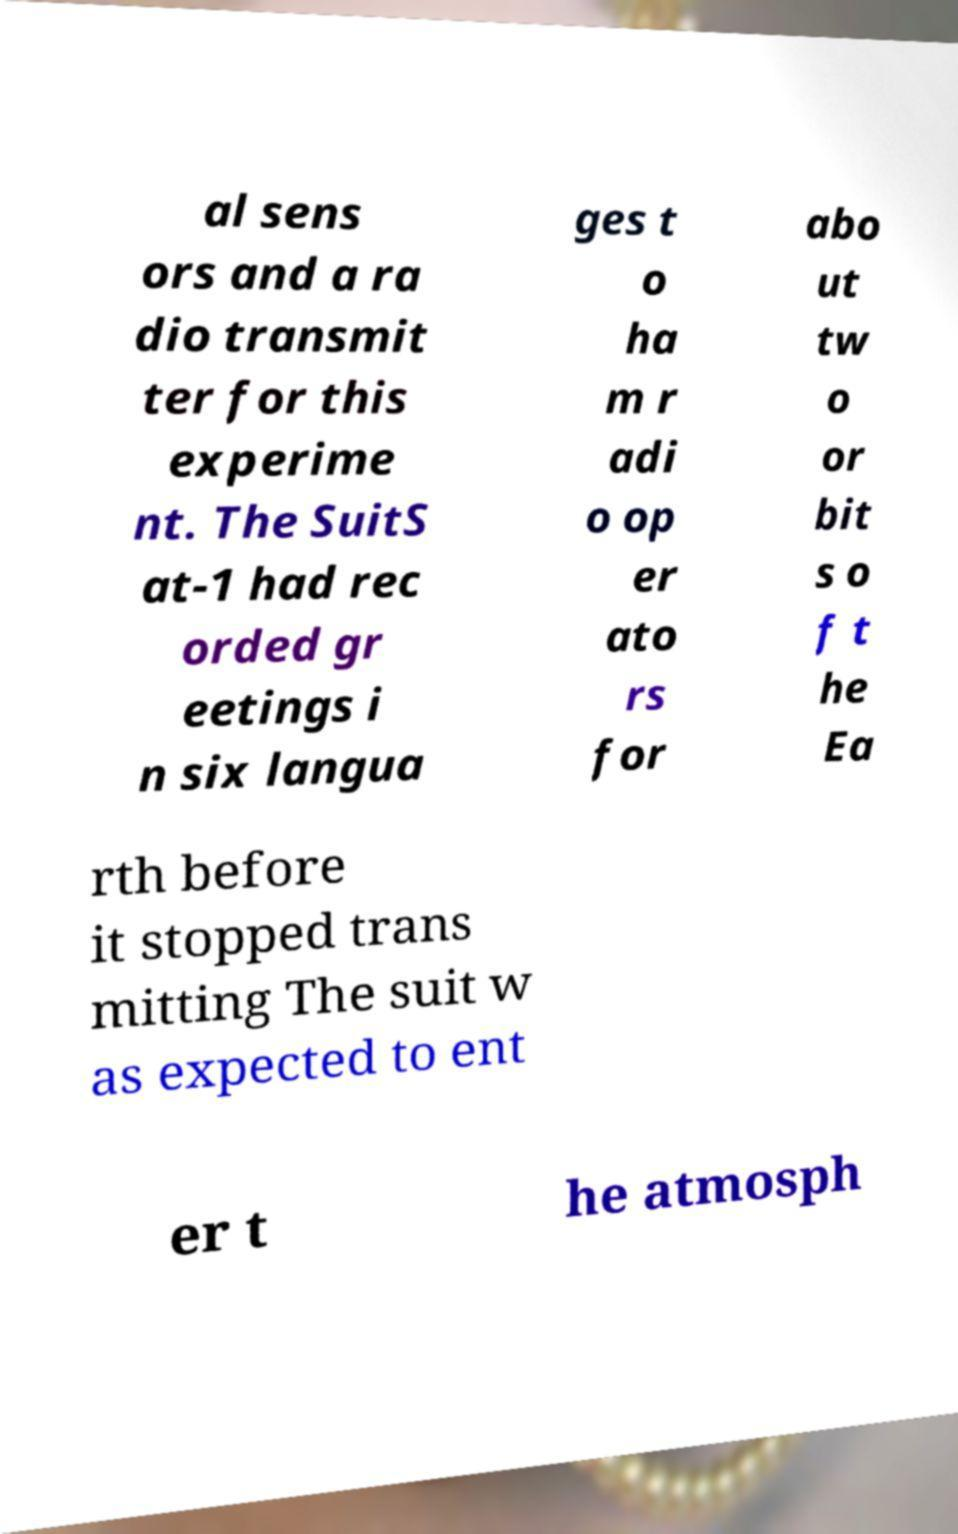Could you assist in decoding the text presented in this image and type it out clearly? al sens ors and a ra dio transmit ter for this experime nt. The SuitS at-1 had rec orded gr eetings i n six langua ges t o ha m r adi o op er ato rs for abo ut tw o or bit s o f t he Ea rth before it stopped trans mitting The suit w as expected to ent er t he atmosph 